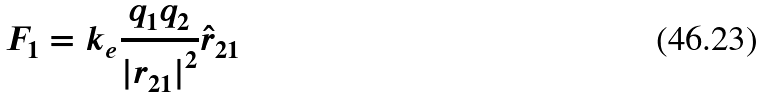Convert formula to latex. <formula><loc_0><loc_0><loc_500><loc_500>F _ { 1 } = k _ { e } \frac { q _ { 1 } q _ { 2 } } { { | r _ { 2 1 } | } ^ { 2 } } \hat { r } _ { 2 1 }</formula> 